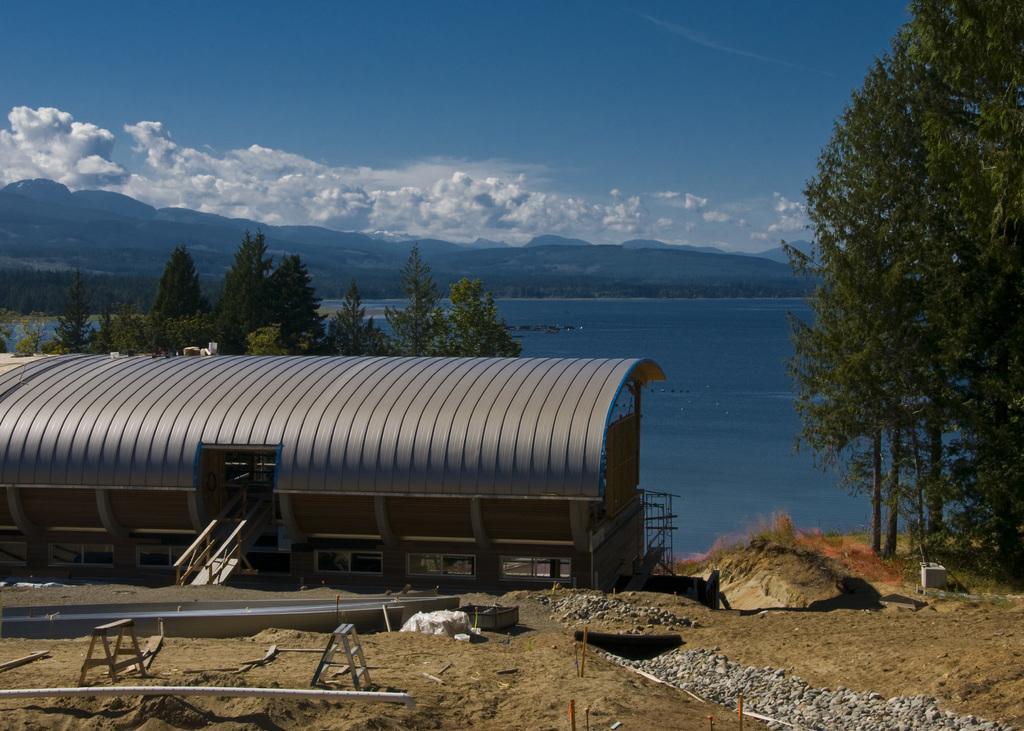Describe this image in one or two sentences. In this image we can see a building. There is a way with railings to the building. Also there are stands. On the ground there is soil and stones. In the background there are trees, water, hills and sky with clouds. 